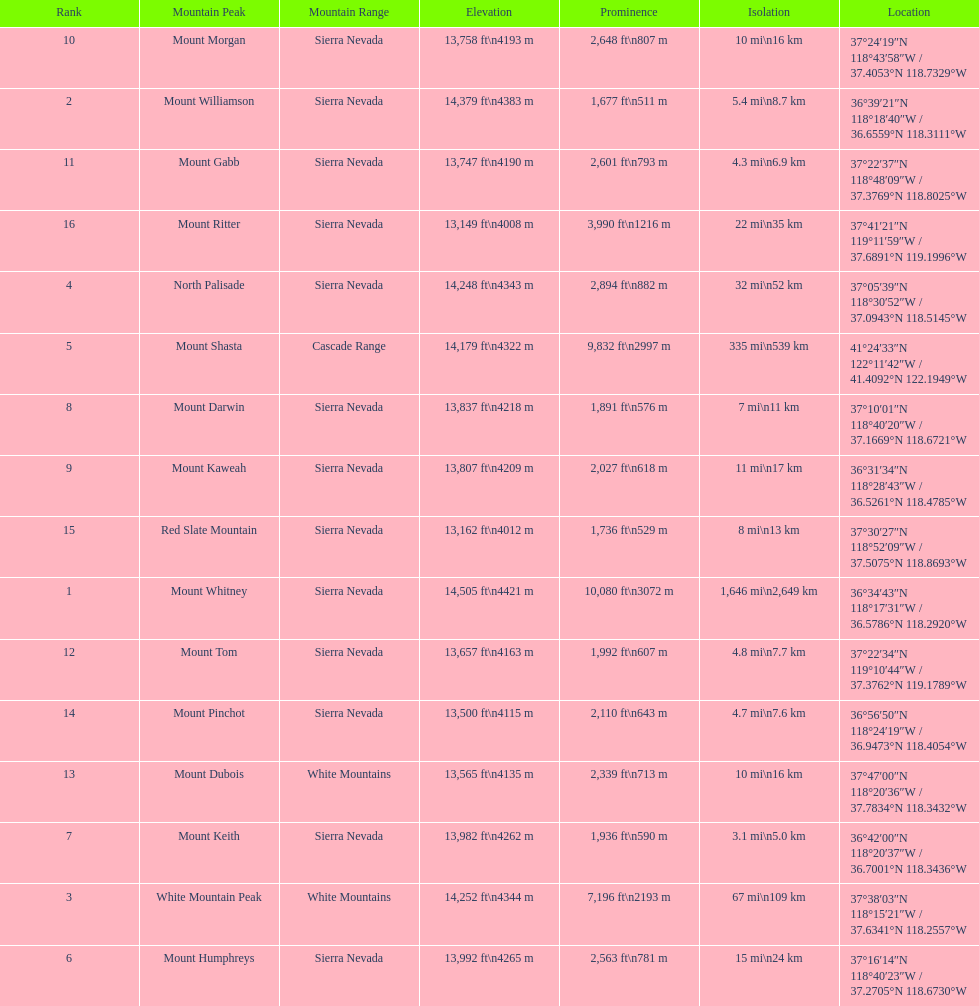Which mountain peak is no higher than 13,149 ft? Mount Ritter. 